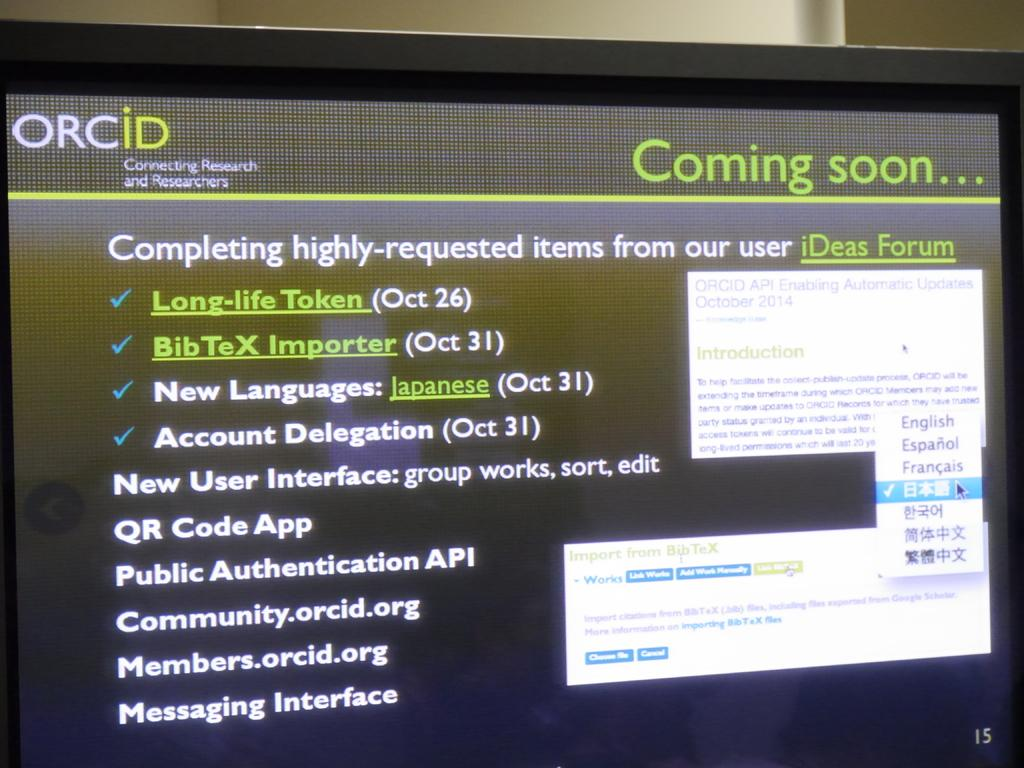<image>
Render a clear and concise summary of the photo. a screen of a computer monitor with the words Coming SOON on it 